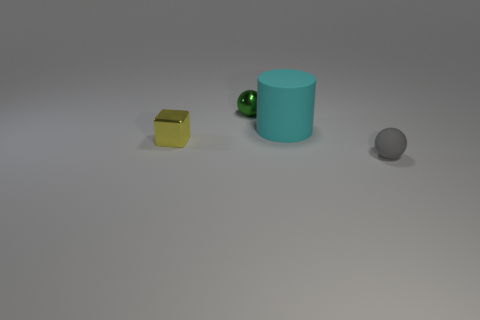Is the size of the green shiny thing the same as the metallic object that is in front of the tiny shiny ball?
Your response must be concise. Yes. The rubber thing that is the same size as the shiny block is what color?
Make the answer very short. Gray. The green object is what size?
Provide a succinct answer. Small. Is the material of the small ball that is in front of the rubber cylinder the same as the cyan thing?
Offer a very short reply. Yes. Is the shape of the gray rubber thing the same as the cyan matte thing?
Your response must be concise. No. What is the shape of the matte object that is behind the ball on the right side of the small ball behind the block?
Provide a short and direct response. Cylinder. There is a thing on the right side of the big cyan rubber cylinder; is it the same shape as the small metal thing that is in front of the big rubber thing?
Your answer should be compact. No. Are there any small cubes made of the same material as the tiny green ball?
Your answer should be compact. Yes. There is a object on the left side of the small green shiny thing behind the metal object in front of the matte cylinder; what color is it?
Your response must be concise. Yellow. Do the ball that is behind the gray thing and the sphere that is in front of the yellow shiny cube have the same material?
Keep it short and to the point. No. 